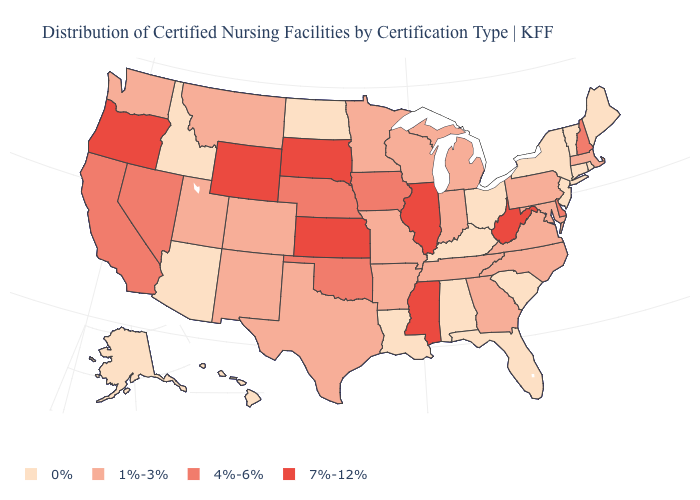Does Washington have a higher value than Kentucky?
Concise answer only. Yes. What is the value of North Carolina?
Answer briefly. 1%-3%. Name the states that have a value in the range 0%?
Be succinct. Alabama, Alaska, Arizona, Connecticut, Florida, Hawaii, Idaho, Kentucky, Louisiana, Maine, New Jersey, New York, North Dakota, Ohio, Rhode Island, South Carolina, Vermont. What is the value of Kentucky?
Write a very short answer. 0%. Name the states that have a value in the range 0%?
Answer briefly. Alabama, Alaska, Arizona, Connecticut, Florida, Hawaii, Idaho, Kentucky, Louisiana, Maine, New Jersey, New York, North Dakota, Ohio, Rhode Island, South Carolina, Vermont. Does Arizona have the highest value in the West?
Concise answer only. No. Name the states that have a value in the range 4%-6%?
Short answer required. California, Delaware, Iowa, Nebraska, Nevada, New Hampshire, Oklahoma. What is the value of Illinois?
Give a very brief answer. 7%-12%. Among the states that border Minnesota , does South Dakota have the highest value?
Concise answer only. Yes. Does Kansas have the lowest value in the MidWest?
Concise answer only. No. How many symbols are there in the legend?
Be succinct. 4. Does Nebraska have a higher value than Vermont?
Keep it brief. Yes. What is the lowest value in the MidWest?
Short answer required. 0%. Does Rhode Island have the lowest value in the USA?
Be succinct. Yes. Which states have the lowest value in the Northeast?
Concise answer only. Connecticut, Maine, New Jersey, New York, Rhode Island, Vermont. 